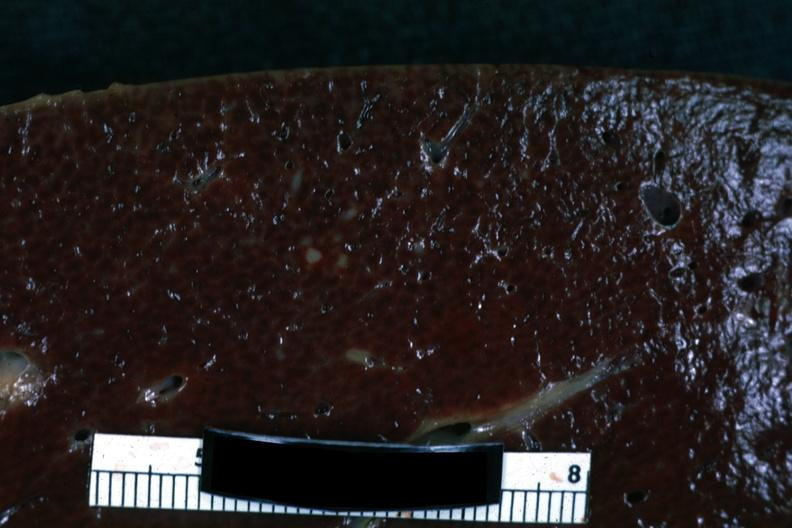s hodgkins disease present?
Answer the question using a single word or phrase. Yes 